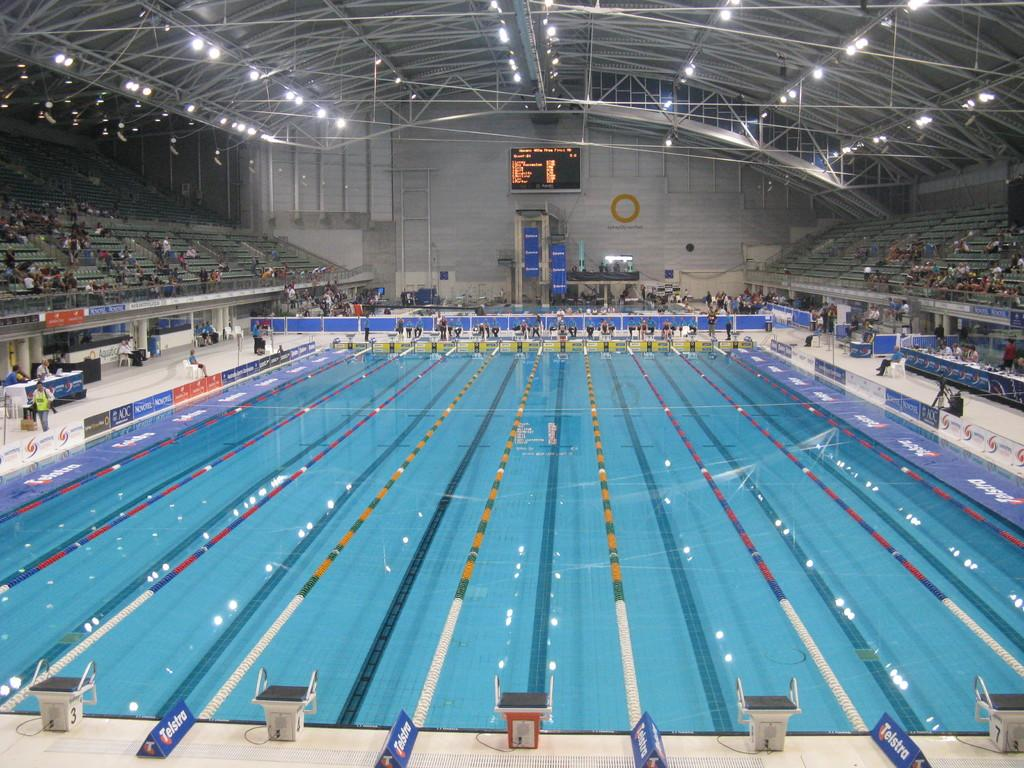What is the main feature of the image? There is a swimming pool in the image. Are there any people present in the image? Yes, there are spectators in the image. What else can be seen in the image besides the swimming pool and spectators? There is a screen and light arrangements on the roof in the image. How many toes does the creature in the image have? There is no creature present in the image, so it is not possible to determine the number of toes it might have. 